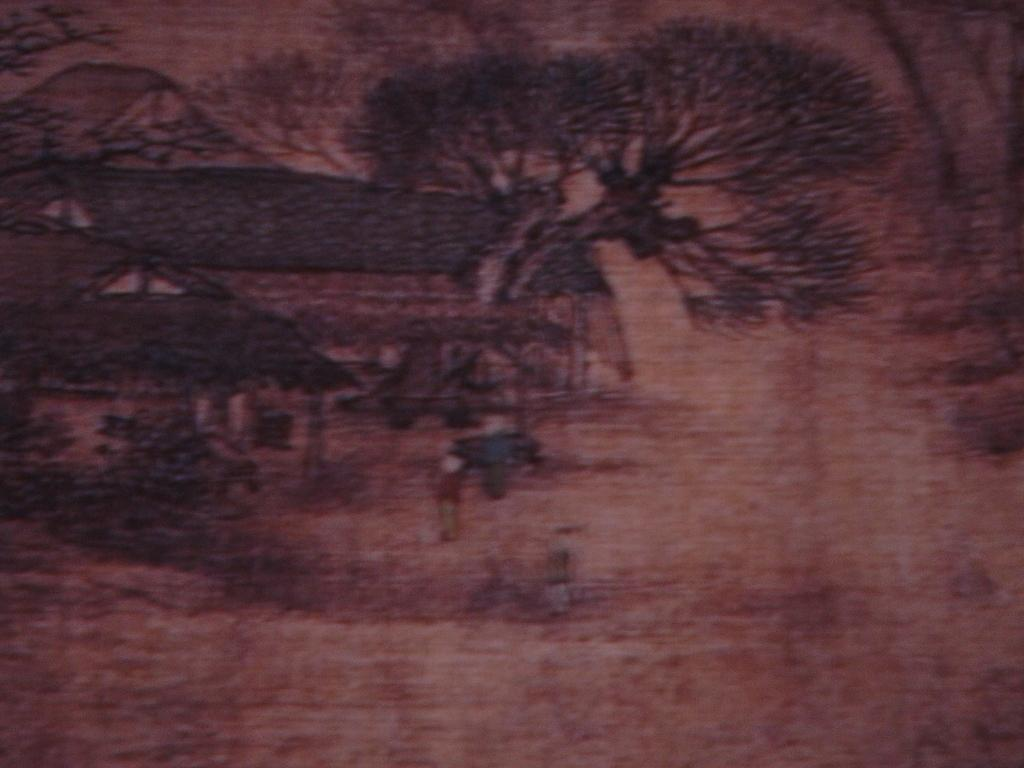What is the overall appearance of the image? The image is dark and slightly blurred. What type of art is depicted in the image? There is an art of houses and trees in the image. What color are the houses and trees in the image? The colors of the houses and trees are brown. Can you see a kitten playing with a ball of yarn in the image? No, there is no kitten or ball of yarn present in the image. What type of addition problem can be solved using the numbers in the image? There are no numbers present in the image, so it is not possible to solve an addition problem. 